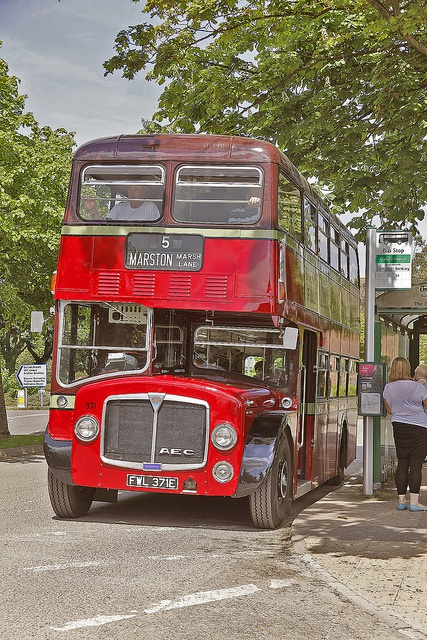Describe the objects in this image and their specific colors. I can see bus in gray, red, black, and darkgray tones, people in gray and black tones, people in gray tones, people in gray, darkgray, and lightgray tones, and people in gray and darkgray tones in this image. 